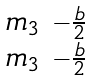<formula> <loc_0><loc_0><loc_500><loc_500>\begin{smallmatrix} m _ { 3 } & - \frac { b } { 2 } \\ m _ { 3 } & - \frac { b } { 2 } \end{smallmatrix}</formula> 